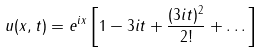Convert formula to latex. <formula><loc_0><loc_0><loc_500><loc_500>u ( x , t ) = e ^ { i x } \left [ 1 - 3 i t + \frac { ( 3 i t ) ^ { 2 } } { 2 ! } + \dots \right ]</formula> 